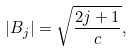<formula> <loc_0><loc_0><loc_500><loc_500>| B _ { j } | = \sqrt { \frac { 2 j + 1 } { c } } ,</formula> 